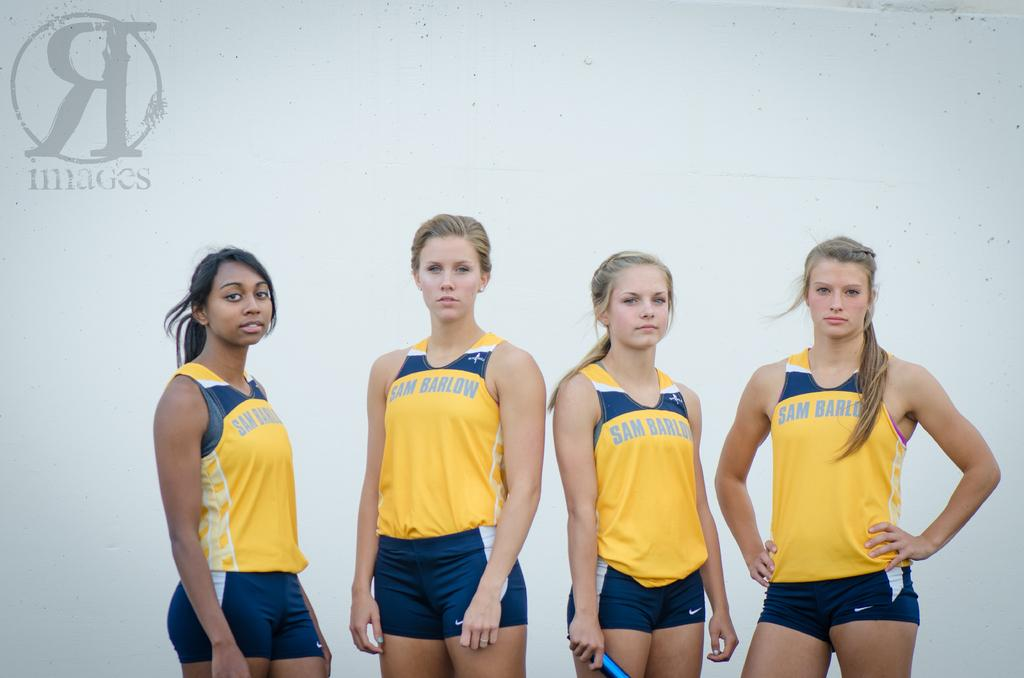<image>
Provide a brief description of the given image. The girls in yellow and blue play sports for Sam Barlow. 